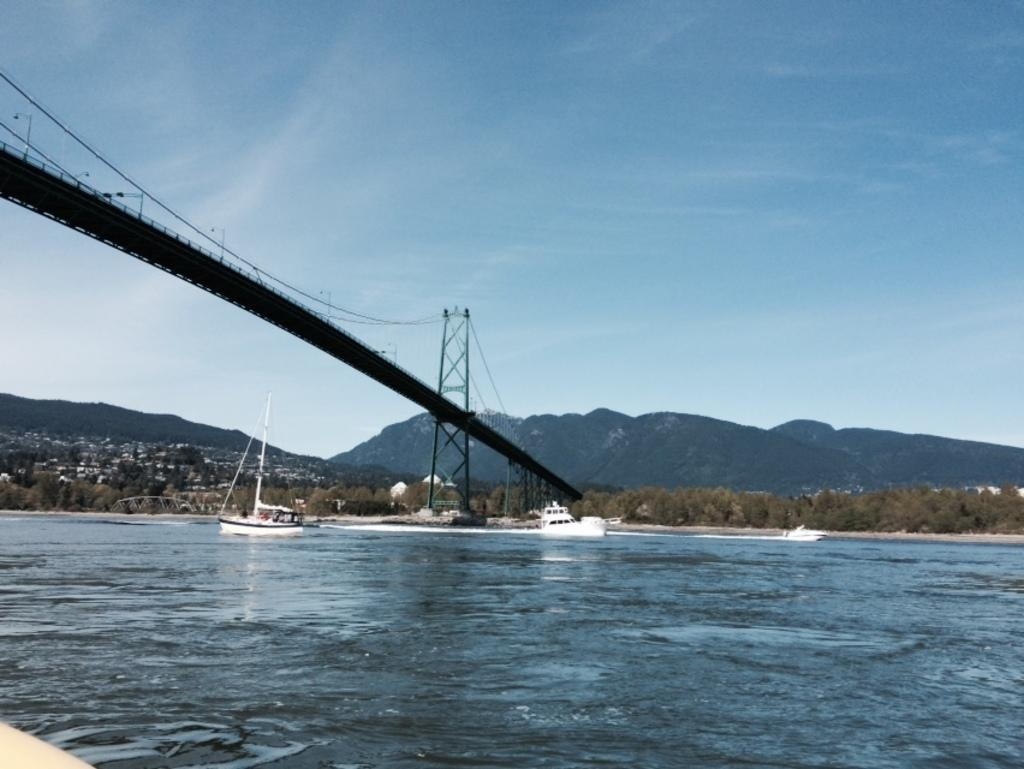What type of vehicles are in the image? There are boats in the image. Where are the boats located? The boats are on the sea. What can be seen in the background of the image? There is a bridge, trees, and mountains visible in the background of the image. What type of chess pieces can be seen on the bridge in the image? There are no chess pieces visible on the bridge in the image. What material is the tin used for in the image? There is no tin present in the image. 